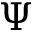Convert formula to latex. <formula><loc_0><loc_0><loc_500><loc_500>\Psi</formula> 